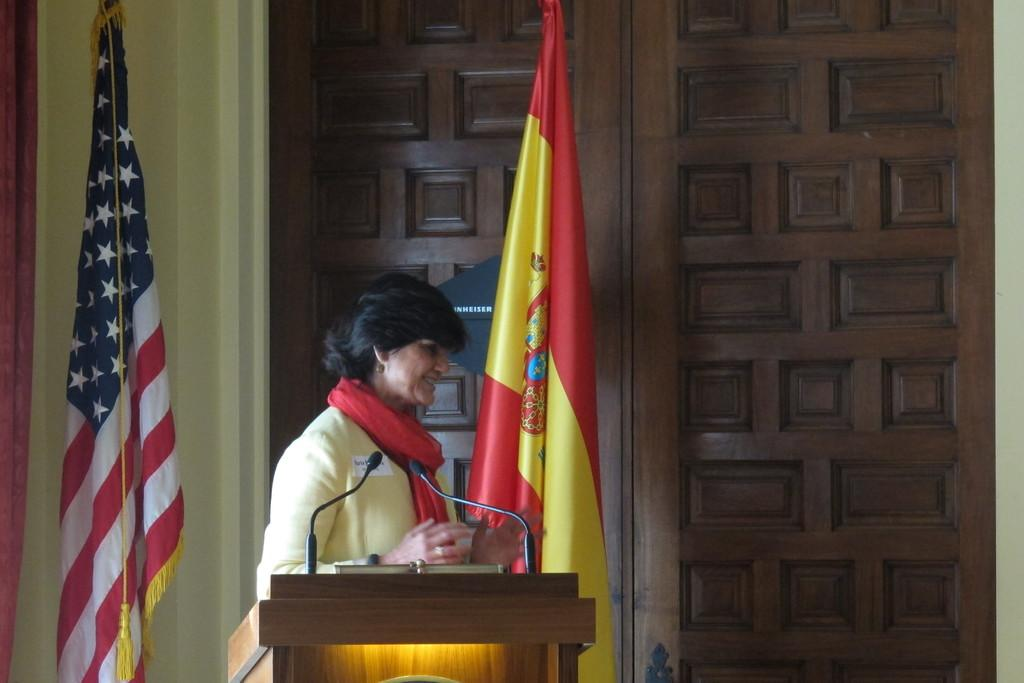What is the lady near in the image? There is a lady standing near a podium in the image. What can be found on the podium? There are microphones on the podium. What can be seen in the background of the image? There are flags, a wall, and a wooden door in the background. Can you see the ocean in the background of the image? No, there is no ocean visible in the background of the image. Is there a stick on the podium with the lady? No, there is no stick present on the podium or in the image. 